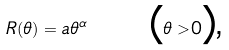Convert formula to latex. <formula><loc_0><loc_0><loc_500><loc_500>R ( \theta ) = a \theta ^ { \alpha } \text { \quad (} \theta > 0 \text {),}</formula> 